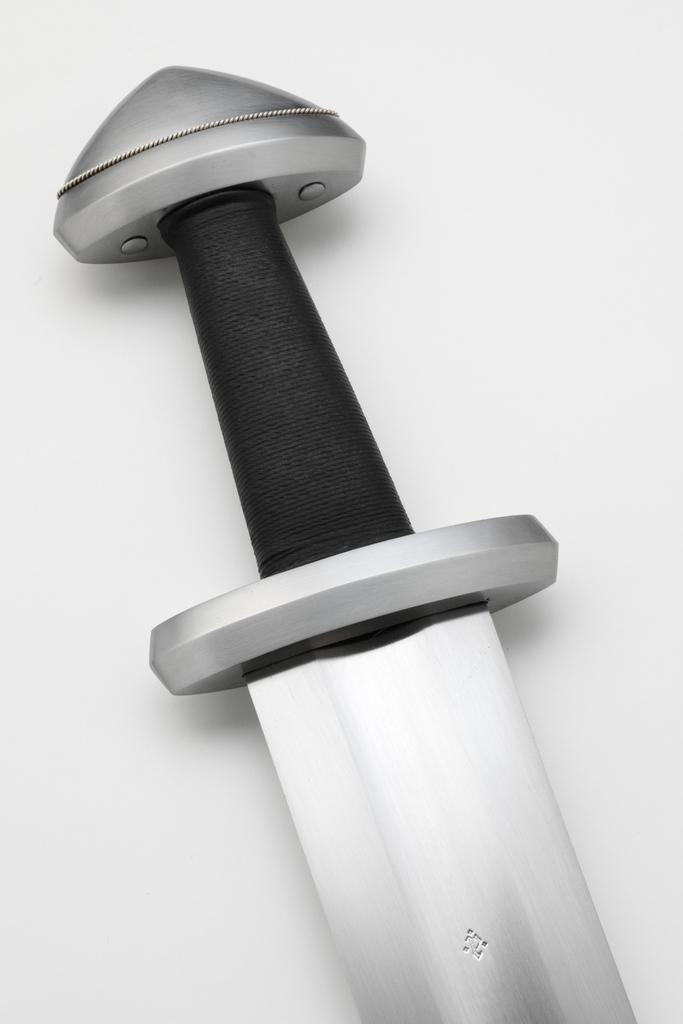What object is the main focus of the image? There is a sword in the image. What is the color of the surface on which the sword is placed? The sword is on a white surface. How many sisters are present in the image? There are no sisters present in the image; it features a sword on a white surface. What type of paper is being used to wrap the sword in the image? There is no paper present in the image; it only shows a sword on a white surface. 